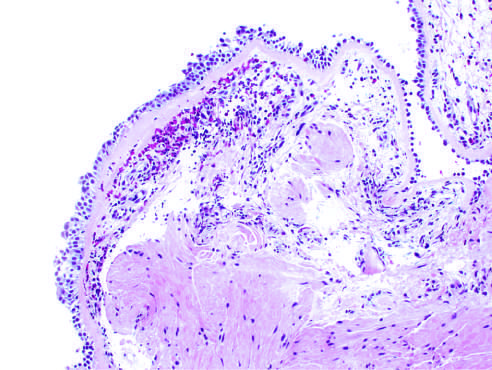do renal tubular epithelial cells in the lower half of the photograph show sub-basement membrane fibrosis, eosinophilic inflammation?
Answer the question using a single word or phrase. No 